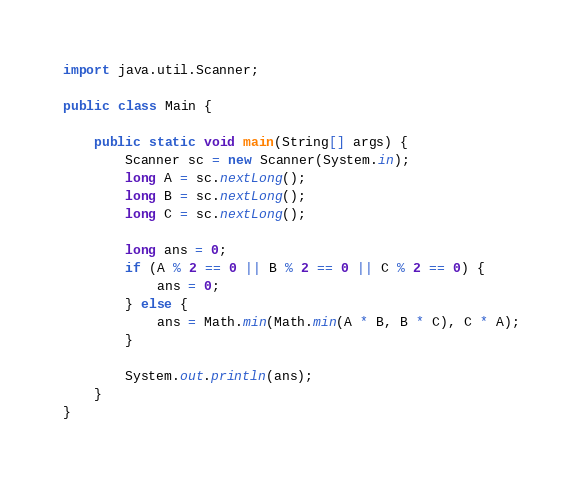Convert code to text. <code><loc_0><loc_0><loc_500><loc_500><_Java_>import java.util.Scanner;

public class Main {

	public static void main(String[] args) {
		Scanner sc = new Scanner(System.in);
		long A = sc.nextLong();
		long B = sc.nextLong();
		long C = sc.nextLong();

		long ans = 0;
		if (A % 2 == 0 || B % 2 == 0 || C % 2 == 0) {
			ans = 0;
		} else {
			ans = Math.min(Math.min(A * B, B * C), C * A);
		}

		System.out.println(ans);
	}
}
</code> 